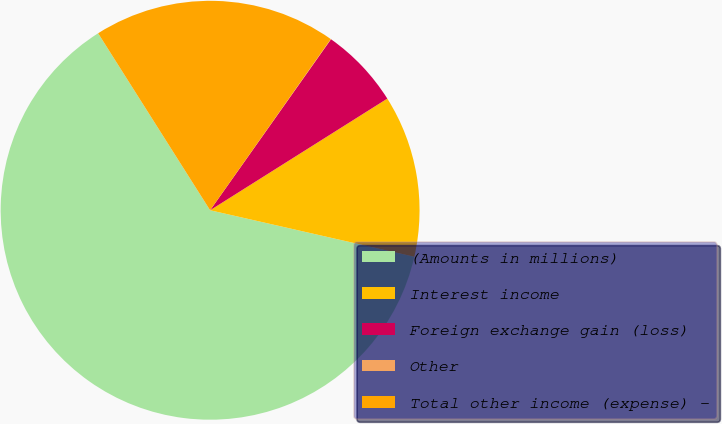<chart> <loc_0><loc_0><loc_500><loc_500><pie_chart><fcel>(Amounts in millions)<fcel>Interest income<fcel>Foreign exchange gain (loss)<fcel>Other<fcel>Total other income (expense) -<nl><fcel>62.46%<fcel>12.51%<fcel>6.26%<fcel>0.02%<fcel>18.75%<nl></chart> 